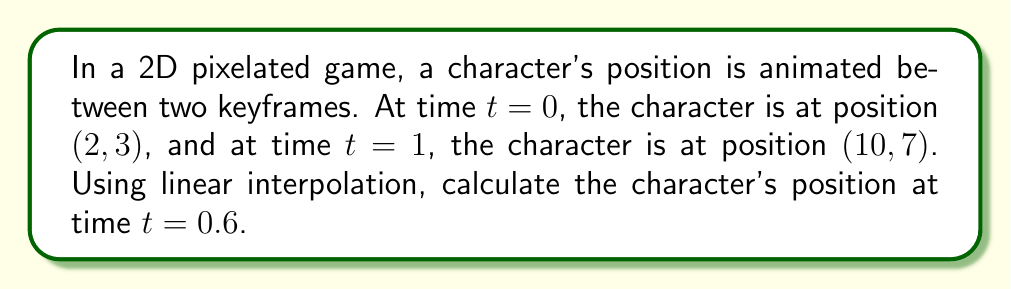Can you answer this question? To solve this problem, we'll use linear interpolation between the two keyframes:

1) Let's define our start and end positions:
   $P_0 = (2, 3)$ at $t=0$
   $P_1 = (10, 7)$ at $t=1$

2) The general formula for linear interpolation is:
   $P(t) = P_0 + t(P_1 - P_0)$, where $t$ is between 0 and 1

3) Let's break this down for x and y coordinates:
   $x(t) = x_0 + t(x_1 - x_0)$
   $y(t) = y_0 + t(y_1 - y_0)$

4) Plugging in our values:
   $x(t) = 2 + t(10 - 2) = 2 + 8t$
   $y(t) = 3 + t(7 - 3) = 3 + 4t$

5) Now, we want to find the position at $t=0.6$:
   $x(0.6) = 2 + 8(0.6) = 2 + 4.8 = 6.8$
   $y(0.6) = 3 + 4(0.6) = 3 + 2.4 = 5.4$

6) Therefore, the interpolated position at $t=0.6$ is $(6.8, 5.4)$

7) Since we're working with pixels, we need to round to the nearest integer:
   $x = \text{round}(6.8) = 7$
   $y = \text{round}(5.4) = 5$
Answer: $(7, 5)$ 